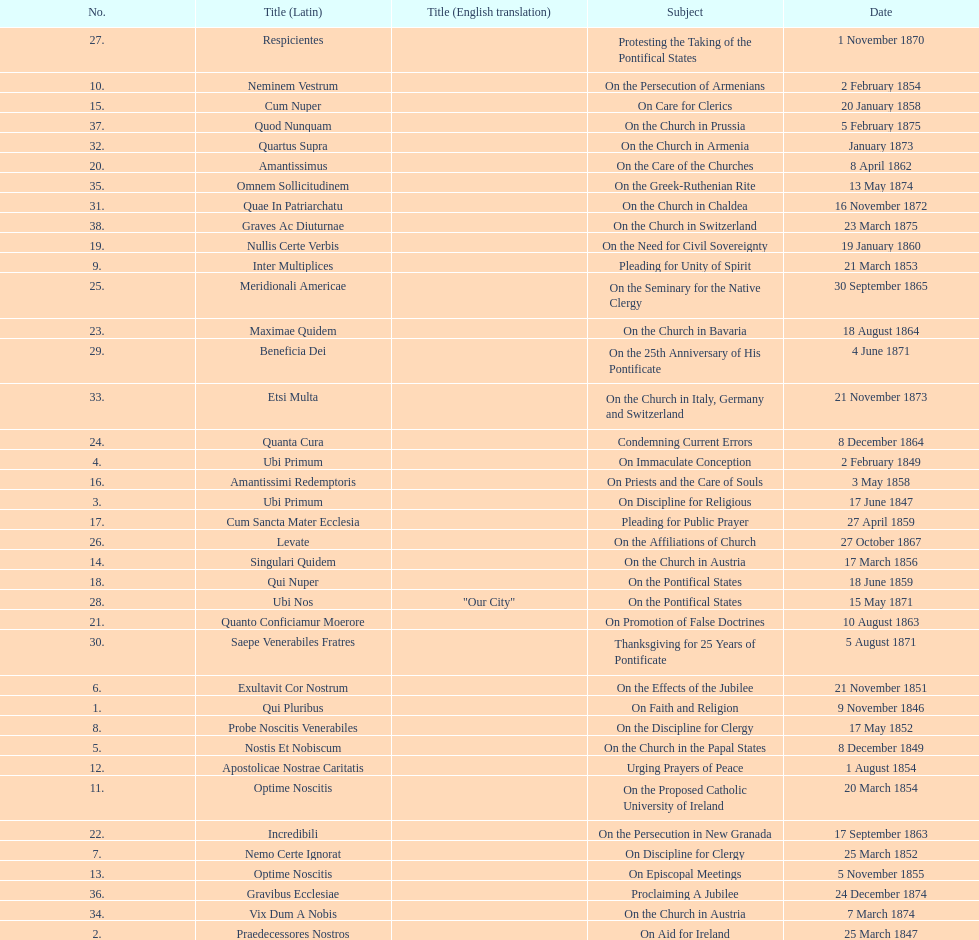How many encyclicals were issued between august 15, 1854 and october 26, 1867? 13. 